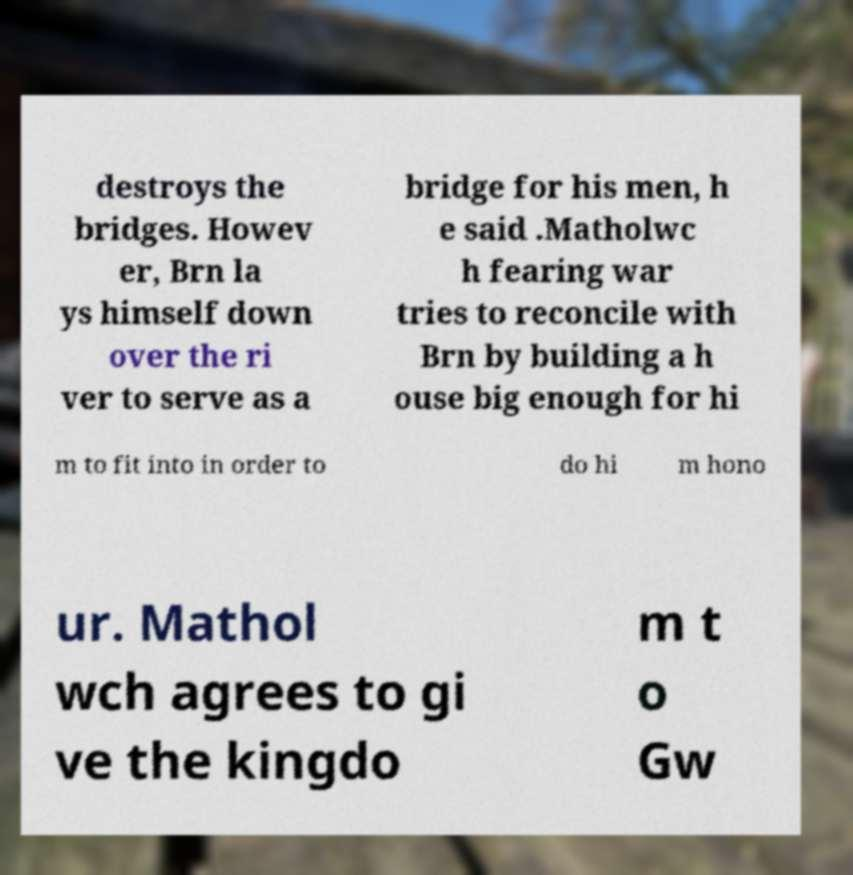What messages or text are displayed in this image? I need them in a readable, typed format. destroys the bridges. Howev er, Brn la ys himself down over the ri ver to serve as a bridge for his men, h e said .Matholwc h fearing war tries to reconcile with Brn by building a h ouse big enough for hi m to fit into in order to do hi m hono ur. Mathol wch agrees to gi ve the kingdo m t o Gw 